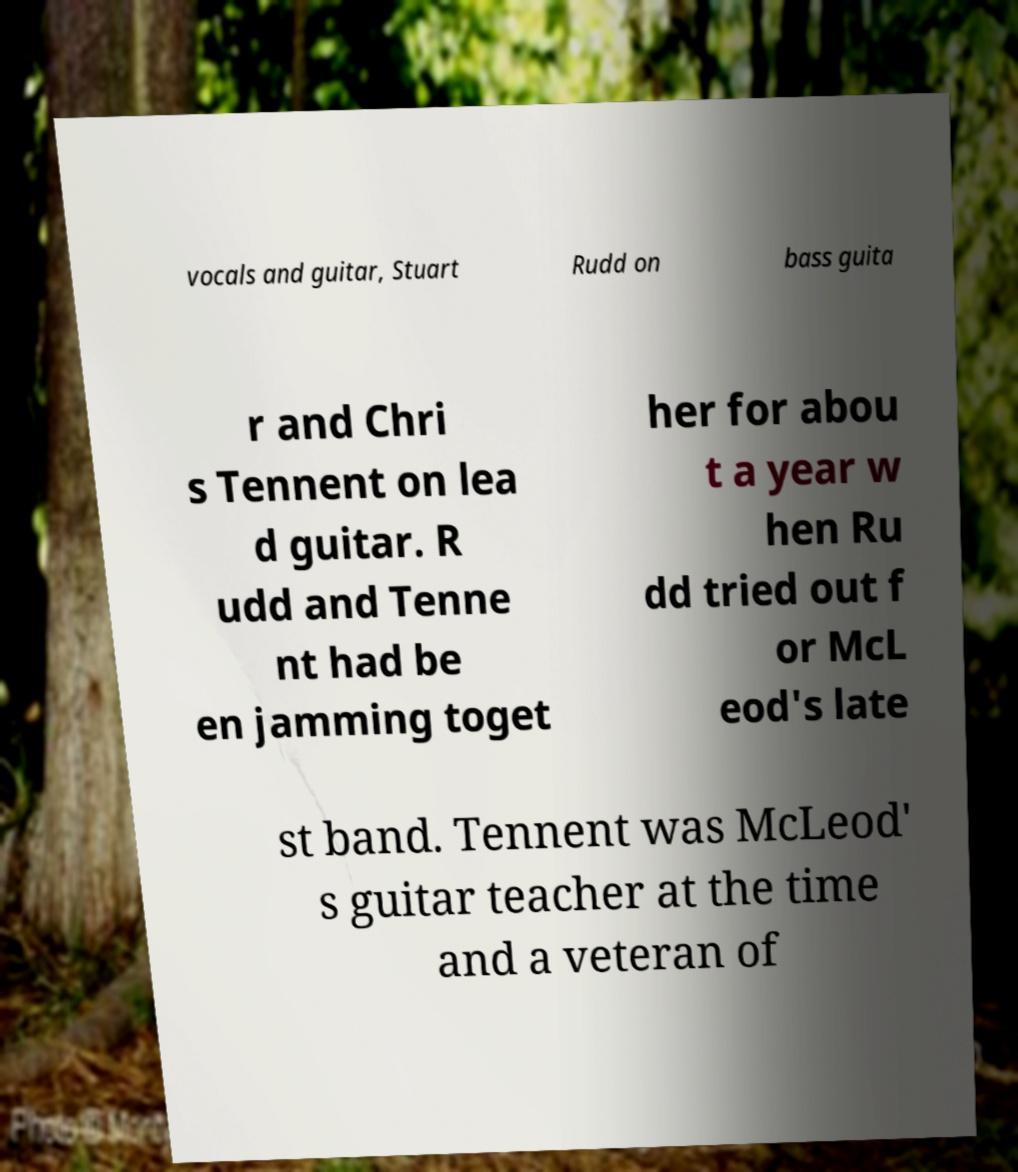Can you accurately transcribe the text from the provided image for me? vocals and guitar, Stuart Rudd on bass guita r and Chri s Tennent on lea d guitar. R udd and Tenne nt had be en jamming toget her for abou t a year w hen Ru dd tried out f or McL eod's late st band. Tennent was McLeod' s guitar teacher at the time and a veteran of 